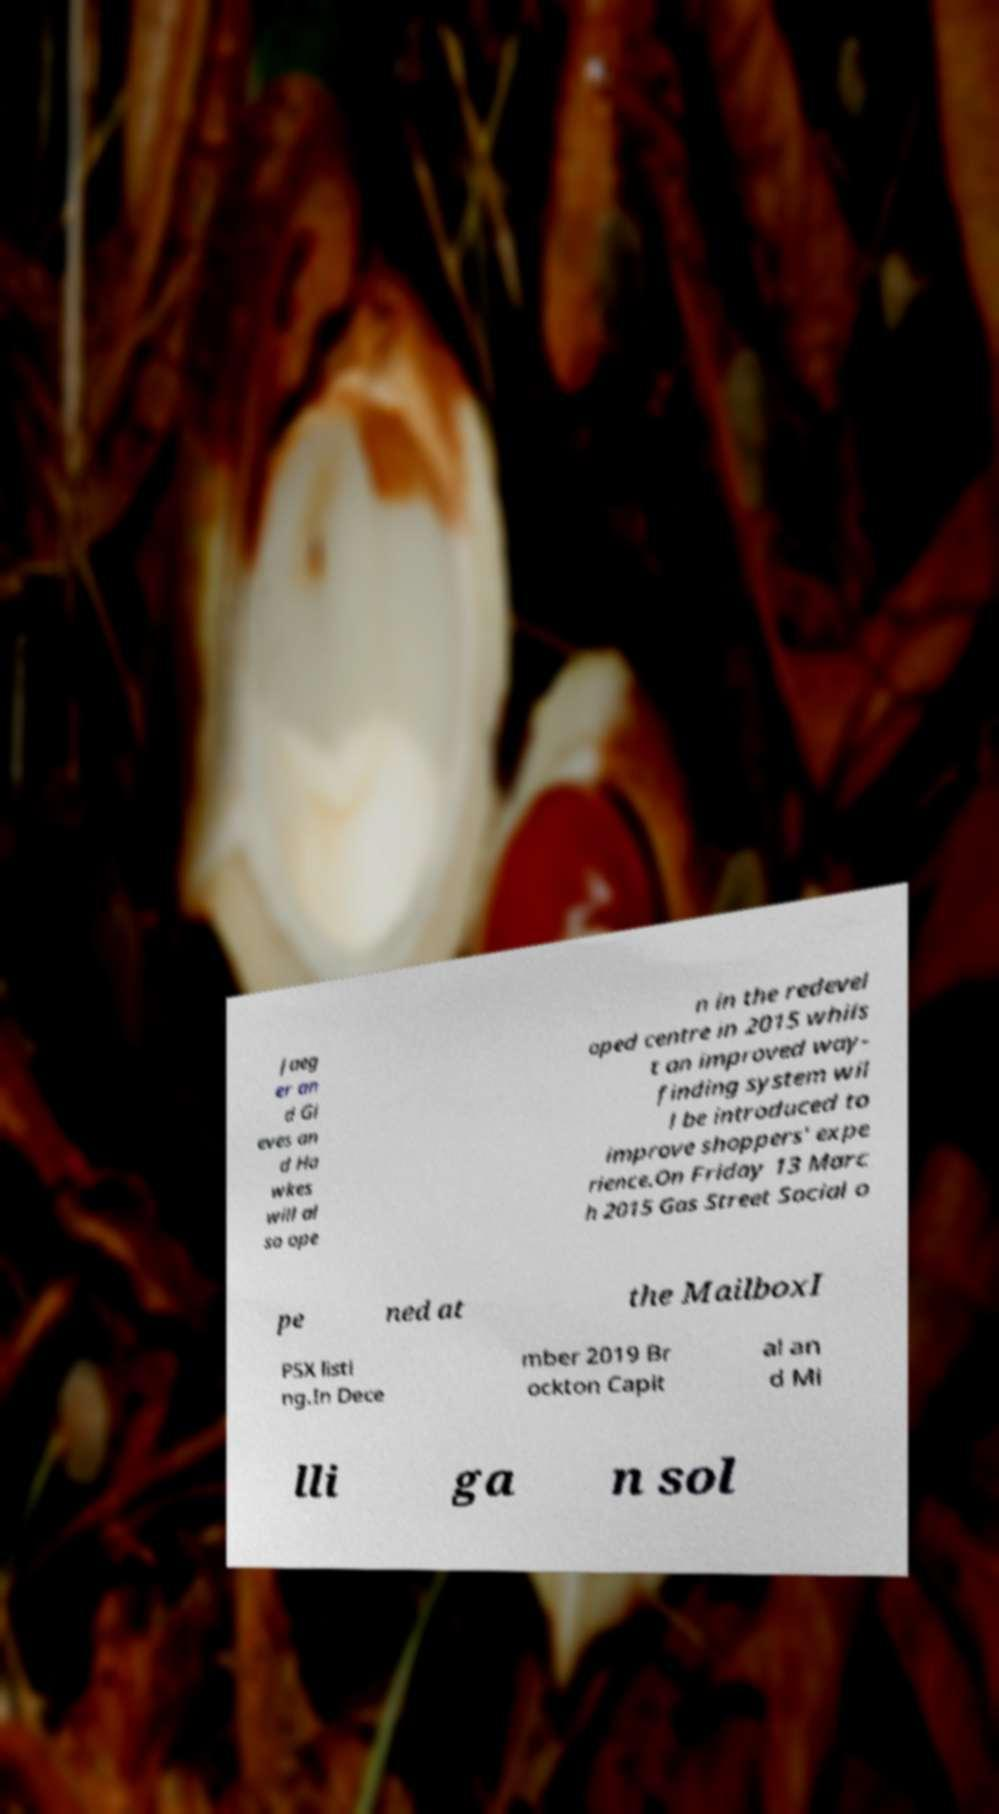Please identify and transcribe the text found in this image. Jaeg er an d Gi eves an d Ha wkes will al so ope n in the redevel oped centre in 2015 whils t an improved way- finding system wil l be introduced to improve shoppers' expe rience.On Friday 13 Marc h 2015 Gas Street Social o pe ned at the MailboxI PSX listi ng.In Dece mber 2019 Br ockton Capit al an d Mi lli ga n sol 